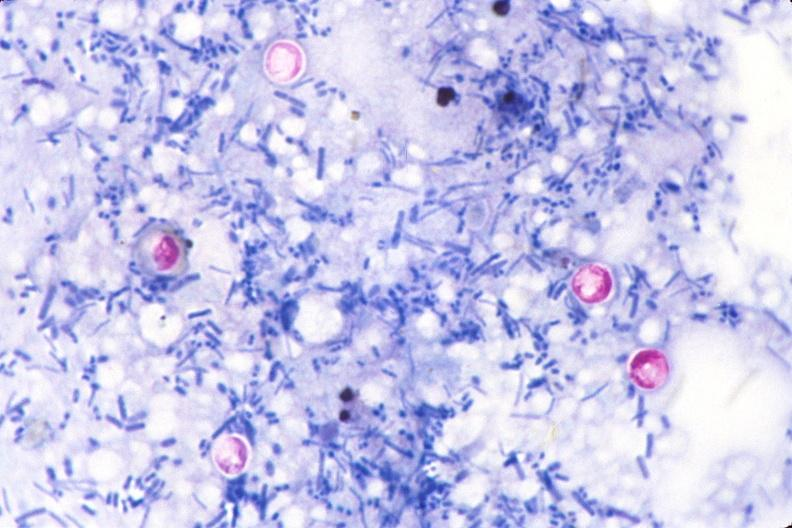does this image show cryptosporidia, acid fast stain of feces?
Answer the question using a single word or phrase. Yes 